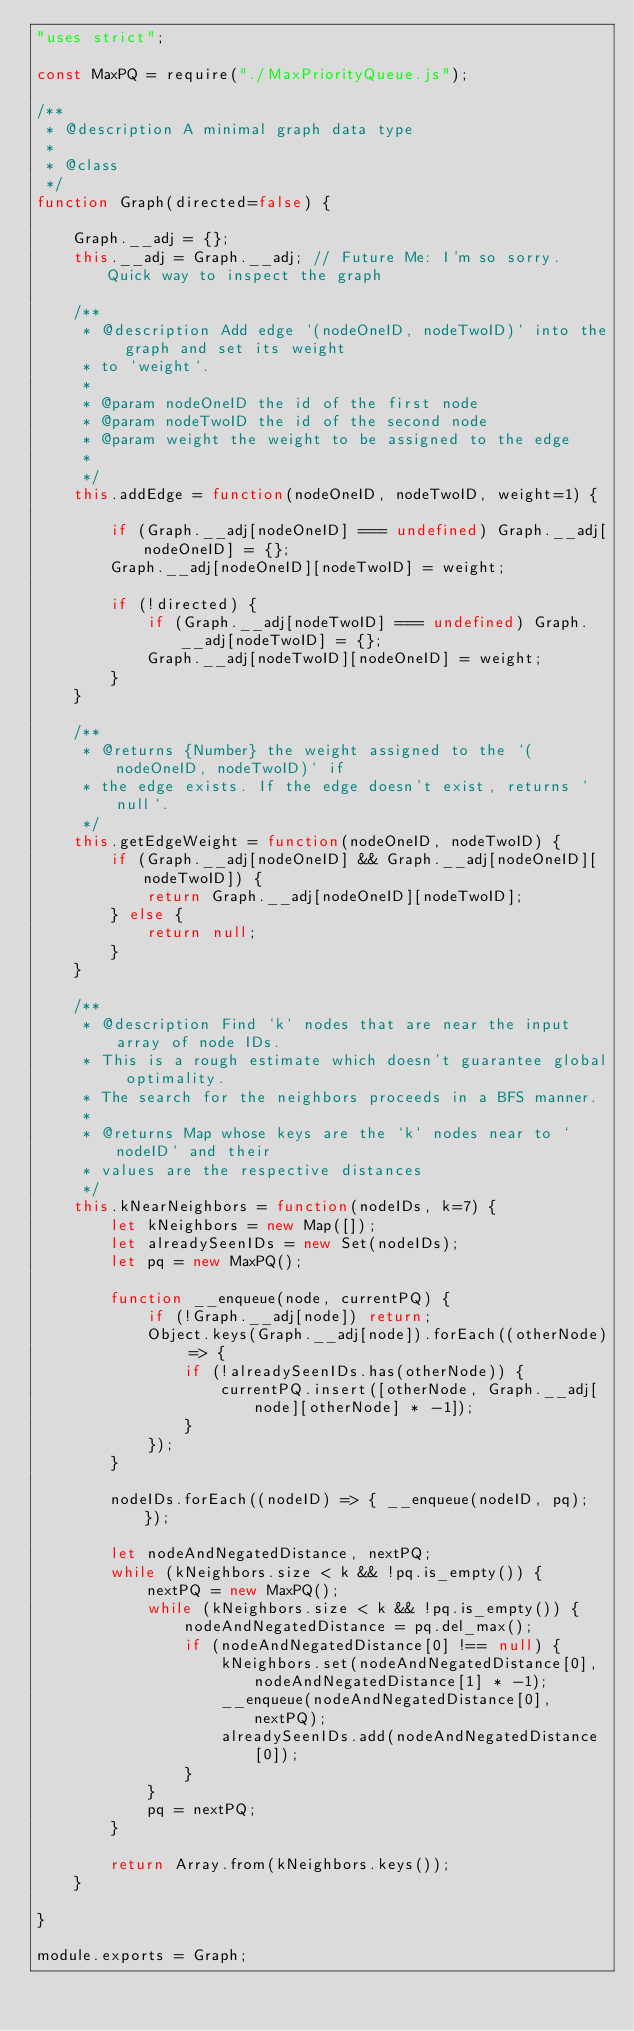<code> <loc_0><loc_0><loc_500><loc_500><_JavaScript_>"uses strict";

const MaxPQ = require("./MaxPriorityQueue.js");

/**
 * @description A minimal graph data type
 * 
 * @class
 */
function Graph(directed=false) {

    Graph.__adj = {};
    this.__adj = Graph.__adj; // Future Me: I'm so sorry. Quick way to inspect the graph

    /**
     * @description Add edge `(nodeOneID, nodeTwoID)` into the graph and set its weight 
     * to `weight`.
     * 
     * @param nodeOneID the id of the first node
     * @param nodeTwoID the id of the second node
     * @param weight the weight to be assigned to the edge
     * 
     */
    this.addEdge = function(nodeOneID, nodeTwoID, weight=1) {

        if (Graph.__adj[nodeOneID] === undefined) Graph.__adj[nodeOneID] = {};
        Graph.__adj[nodeOneID][nodeTwoID] = weight;

        if (!directed) {
            if (Graph.__adj[nodeTwoID] === undefined) Graph.__adj[nodeTwoID] = {};
            Graph.__adj[nodeTwoID][nodeOneID] = weight;
        }
    }

    /**
     * @returns {Number} the weight assigned to the `(nodeOneID, nodeTwoID)` if 
     * the edge exists. If the edge doesn't exist, returns `null`.
     */
    this.getEdgeWeight = function(nodeOneID, nodeTwoID) {
        if (Graph.__adj[nodeOneID] && Graph.__adj[nodeOneID][nodeTwoID]) {
            return Graph.__adj[nodeOneID][nodeTwoID];
        } else {
            return null;
        }
    }

    /**
     * @description Find `k` nodes that are near the input array of node IDs. 
     * This is a rough estimate which doesn't guarantee global optimality. 
     * The search for the neighbors proceeds in a BFS manner.
     * 
     * @returns Map whose keys are the `k` nodes near to `nodeID` and their 
     * values are the respective distances
     */
    this.kNearNeighbors = function(nodeIDs, k=7) {
        let kNeighbors = new Map([]);
        let alreadySeenIDs = new Set(nodeIDs);
        let pq = new MaxPQ();

        function __enqueue(node, currentPQ) {
            if (!Graph.__adj[node]) return;
            Object.keys(Graph.__adj[node]).forEach((otherNode) => {
                if (!alreadySeenIDs.has(otherNode)) {
                    currentPQ.insert([otherNode, Graph.__adj[node][otherNode] * -1]);
                }
            });
        }

        nodeIDs.forEach((nodeID) => { __enqueue(nodeID, pq); });
        
        let nodeAndNegatedDistance, nextPQ;
        while (kNeighbors.size < k && !pq.is_empty()) {
            nextPQ = new MaxPQ();
            while (kNeighbors.size < k && !pq.is_empty()) {
                nodeAndNegatedDistance = pq.del_max();
                if (nodeAndNegatedDistance[0] !== null) {
                    kNeighbors.set(nodeAndNegatedDistance[0], nodeAndNegatedDistance[1] * -1);
                    __enqueue(nodeAndNegatedDistance[0], nextPQ);
                    alreadySeenIDs.add(nodeAndNegatedDistance[0]);
                }
            }
            pq = nextPQ;
        }

        return Array.from(kNeighbors.keys());
    }

}

module.exports = Graph;
</code> 